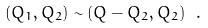<formula> <loc_0><loc_0><loc_500><loc_500>( Q _ { 1 } , Q _ { 2 } ) \sim ( Q - Q _ { 2 } , Q _ { 2 } ) \ .</formula> 